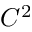<formula> <loc_0><loc_0><loc_500><loc_500>C ^ { 2 }</formula> 